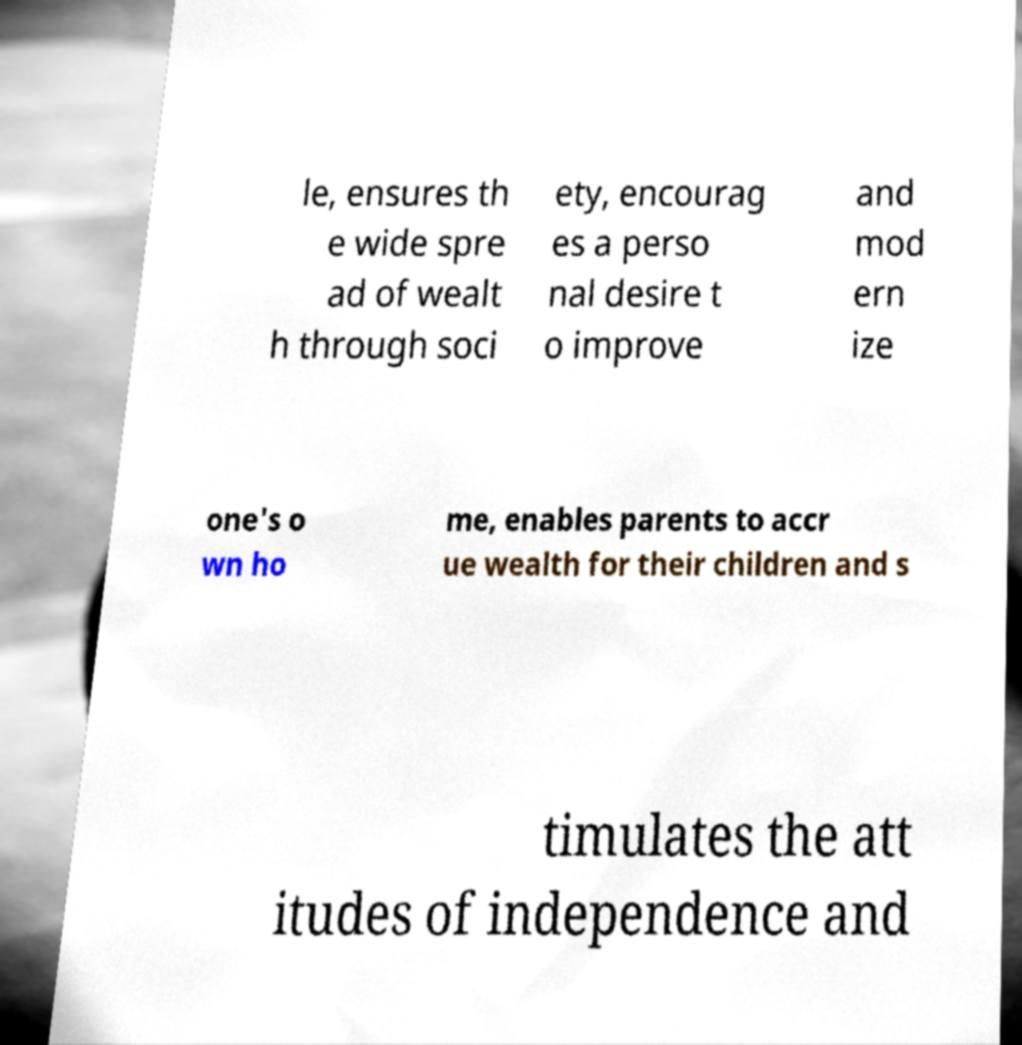Can you read and provide the text displayed in the image?This photo seems to have some interesting text. Can you extract and type it out for me? le, ensures th e wide spre ad of wealt h through soci ety, encourag es a perso nal desire t o improve and mod ern ize one's o wn ho me, enables parents to accr ue wealth for their children and s timulates the att itudes of independence and 